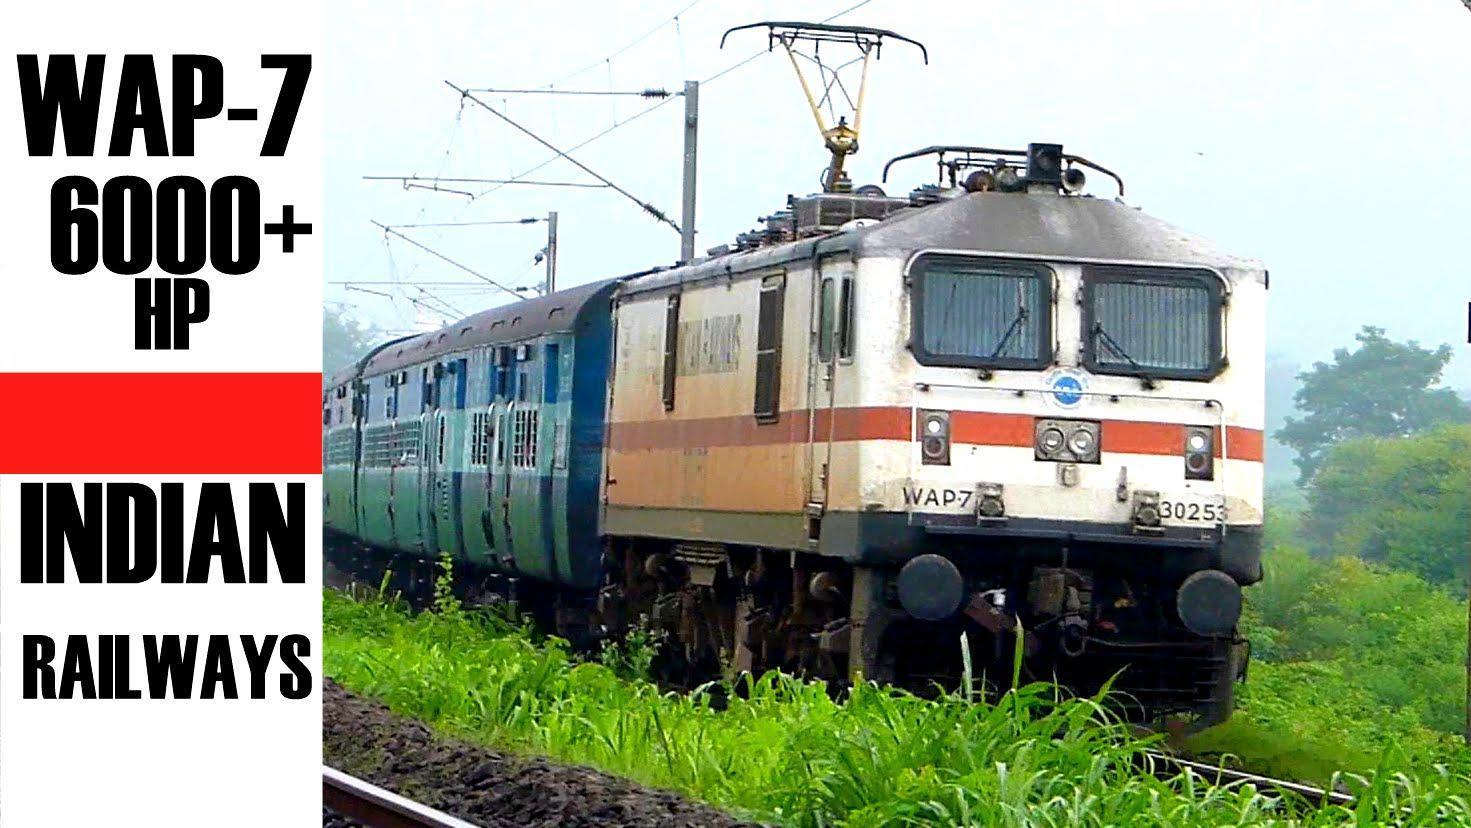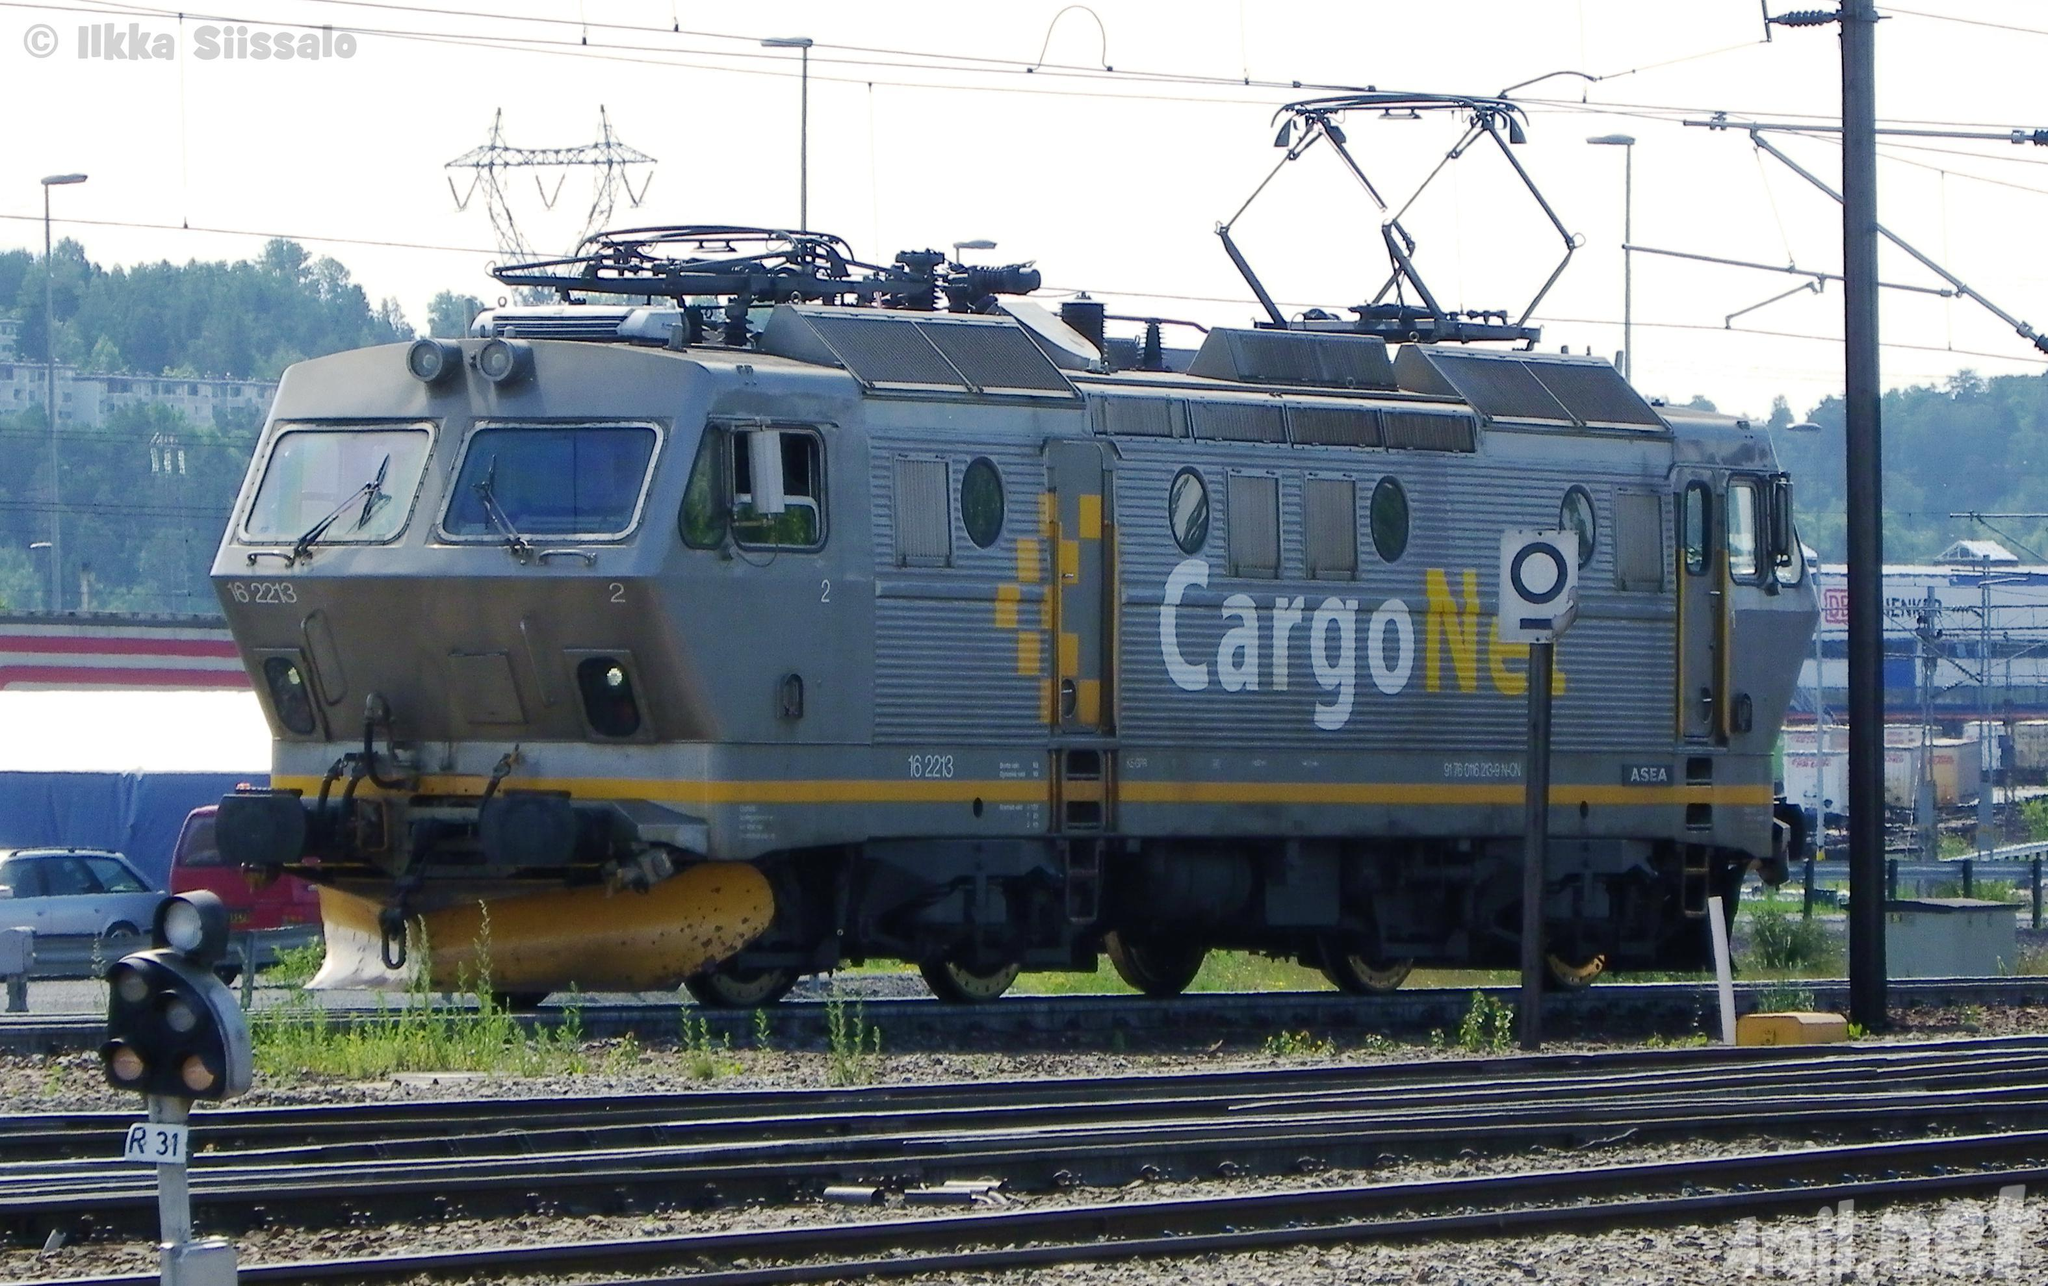The first image is the image on the left, the second image is the image on the right. Considering the images on both sides, is "The train engine in one of the images is bright red." valid? Answer yes or no. No. 